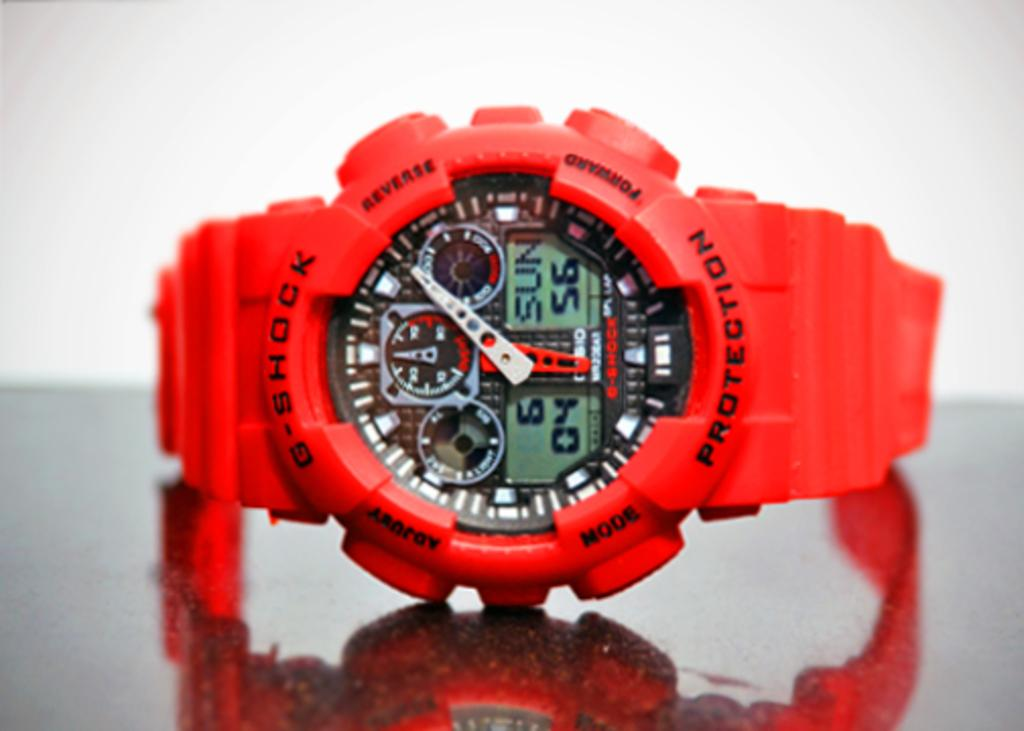What color is the watch in the image? The watch in the image is red-colored. Are there any words or letters on the watch? Yes, the watch has text on it. Can you describe the reflection of the watch in the image? There is a reflection of the watch on the surface of a table in the image. Where is the queen standing in the image? There is no queen present in the image; it only features a red-colored watch. What type of neck accessory is visible in the image? There is no neck accessory present in the image; it only features a red-colored watch. 